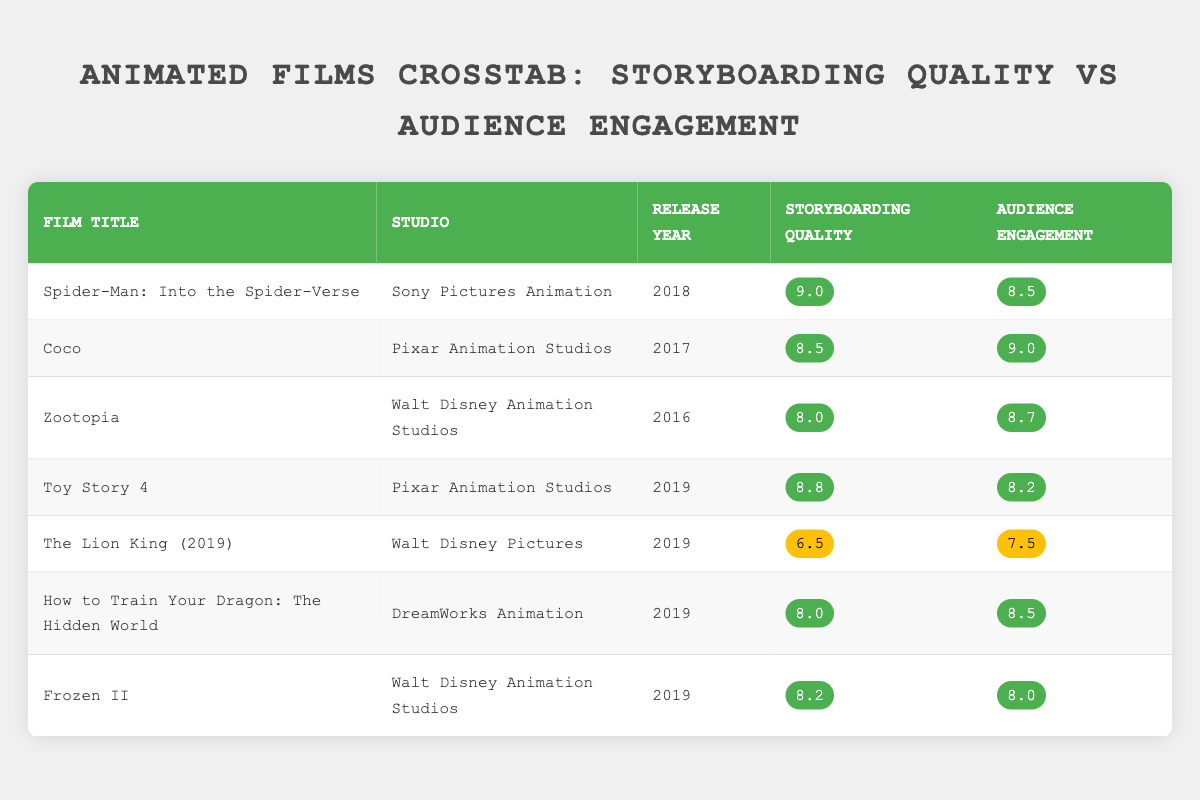What is the storyboarding quality of "Coco"? The table lists "Coco" with a storyboarding quality rating of 8.5.
Answer: 8.5 Which animated film had the highest audience engagement score? By looking through the audience engagement column, "Coco" has the highest score of 9.0.
Answer: Coco What is the average storyboarding quality of the films released in 2019? The films from 2019 are "Toy Story 4," "The Lion King (2019)," "How to Train Your Dragon: The Hidden World," and "Frozen II." Their storyboarding ratings are 8.8, 6.5, 8.0, and 8.2. The sum is 31.5, and with 4 films, the average is calculated as 31.5/4 = 7.875.
Answer: 7.875 Did any films from Pixar Animation Studios receive a storyboarding quality rating above 8.5? The films "Coco" and "Toy Story 4," both from Pixar, received ratings of 8.5 and 8.8 respectively, therefore yes, they did receive above 8.5.
Answer: Yes Which studio has animated films with the lowest average audience engagement score? The audience engagement scores for films from each studio can be calculated: Sony Pictures Animation (8.5), Pixar Animation Studios [(9.0 + 8.2)/2 = 8.6], Walt Disney Animation Studios [(8.7 + 8.0)/2 = 8.35], and DreamWorks Animation (8.5). Walt Disney Animation Studios has the lowest average audience engagement score of 8.35.
Answer: Walt Disney Animation Studios What is the difference between the highest and lowest storyboarding quality scores? The highest storyboarding quality is 9.0 (from "Spider-Man: Into the Spider-Verse") and the lowest is 6.5 (from "The Lion King (2019)"). The difference is 9.0 - 6.5 = 2.5.
Answer: 2.5 Are there any animated films from Walt Disney Animation Studios that scored higher than 8.0 in storyboarding quality? Yes, "Zootopia" scored 8.0 and "Frozen II" scored 8.2, both of which are above 8.0 in storyboarding quality.
Answer: Yes Which film had a storyboarding quality lower than 7 but higher than 6? From the table, "The Lion King (2019)" scored 6.5, which is the only film that fits between those scores.
Answer: The Lion King (2019) How many films from DreamWorks Animation had an audience engagement score above 8? The films from DreamWorks Animation is "How to Train Your Dragon: The Hidden World," which scored 8.5, as the only film fitting this criterion.
Answer: 1 